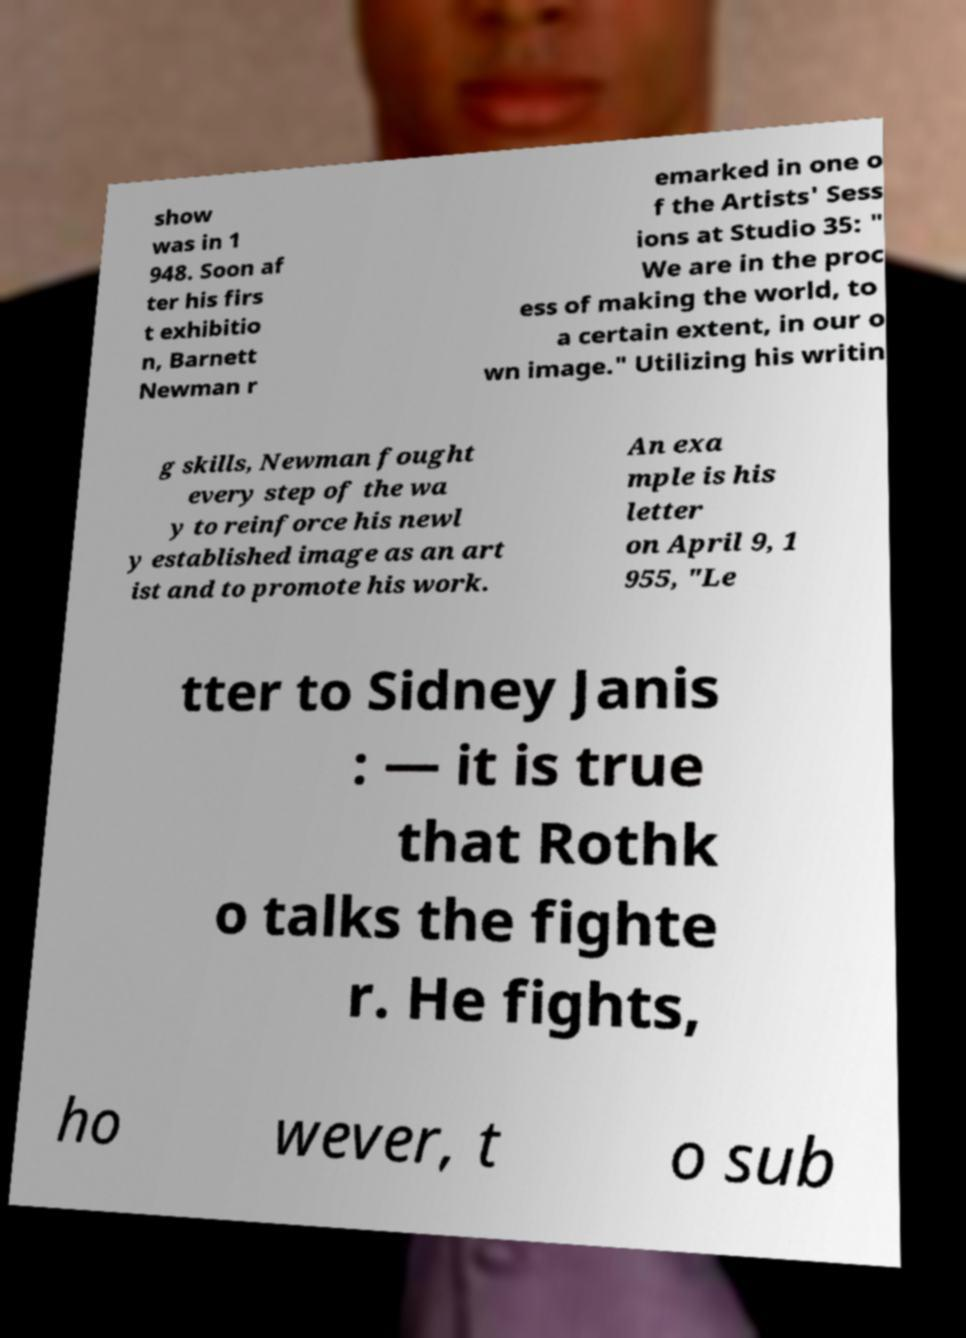Can you accurately transcribe the text from the provided image for me? show was in 1 948. Soon af ter his firs t exhibitio n, Barnett Newman r emarked in one o f the Artists' Sess ions at Studio 35: " We are in the proc ess of making the world, to a certain extent, in our o wn image." Utilizing his writin g skills, Newman fought every step of the wa y to reinforce his newl y established image as an art ist and to promote his work. An exa mple is his letter on April 9, 1 955, "Le tter to Sidney Janis : — it is true that Rothk o talks the fighte r. He fights, ho wever, t o sub 